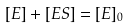Convert formula to latex. <formula><loc_0><loc_0><loc_500><loc_500>[ E ] + [ E S ] = [ E ] _ { 0 }</formula> 